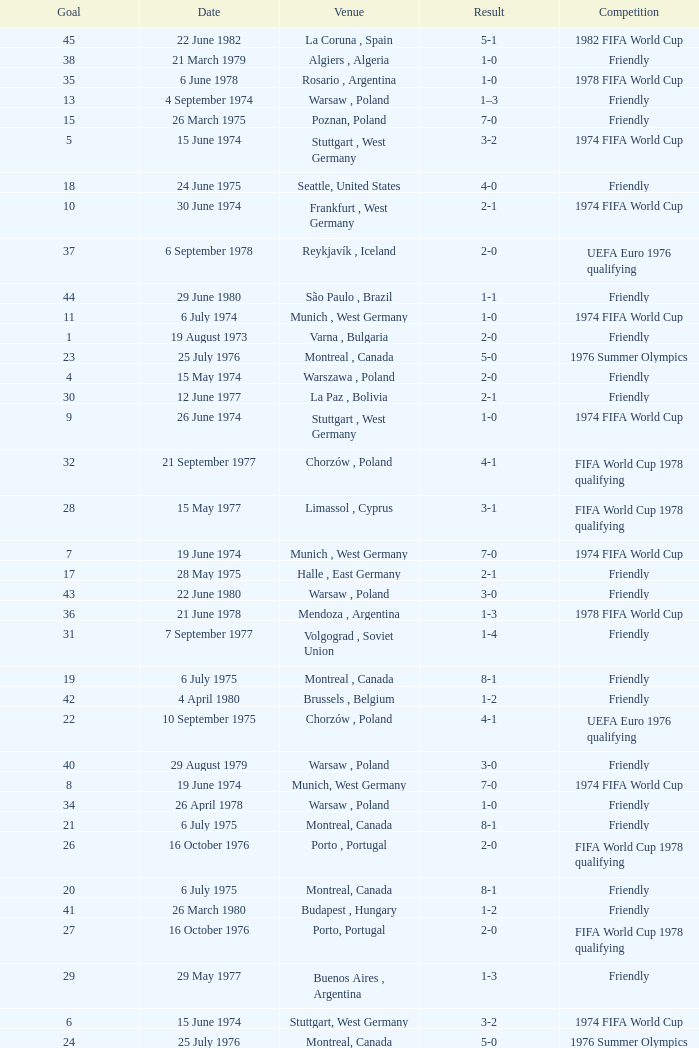Parse the table in full. {'header': ['Goal', 'Date', 'Venue', 'Result', 'Competition'], 'rows': [['45', '22 June 1982', 'La Coruna , Spain', '5-1', '1982 FIFA World Cup'], ['38', '21 March 1979', 'Algiers , Algeria', '1-0', 'Friendly'], ['35', '6 June 1978', 'Rosario , Argentina', '1-0', '1978 FIFA World Cup'], ['13', '4 September 1974', 'Warsaw , Poland', '1–3', 'Friendly'], ['15', '26 March 1975', 'Poznan, Poland', '7-0', 'Friendly'], ['5', '15 June 1974', 'Stuttgart , West Germany', '3-2', '1974 FIFA World Cup'], ['18', '24 June 1975', 'Seattle, United States', '4-0', 'Friendly'], ['10', '30 June 1974', 'Frankfurt , West Germany', '2-1', '1974 FIFA World Cup'], ['37', '6 September 1978', 'Reykjavík , Iceland', '2-0', 'UEFA Euro 1976 qualifying'], ['44', '29 June 1980', 'São Paulo , Brazil', '1-1', 'Friendly'], ['11', '6 July 1974', 'Munich , West Germany', '1-0', '1974 FIFA World Cup'], ['1', '19 August 1973', 'Varna , Bulgaria', '2-0', 'Friendly'], ['23', '25 July 1976', 'Montreal , Canada', '5-0', '1976 Summer Olympics'], ['4', '15 May 1974', 'Warszawa , Poland', '2-0', 'Friendly'], ['30', '12 June 1977', 'La Paz , Bolivia', '2-1', 'Friendly'], ['9', '26 June 1974', 'Stuttgart , West Germany', '1-0', '1974 FIFA World Cup'], ['32', '21 September 1977', 'Chorzów , Poland', '4-1', 'FIFA World Cup 1978 qualifying'], ['28', '15 May 1977', 'Limassol , Cyprus', '3-1', 'FIFA World Cup 1978 qualifying'], ['7', '19 June 1974', 'Munich , West Germany', '7-0', '1974 FIFA World Cup'], ['17', '28 May 1975', 'Halle , East Germany', '2-1', 'Friendly'], ['43', '22 June 1980', 'Warsaw , Poland', '3-0', 'Friendly'], ['36', '21 June 1978', 'Mendoza , Argentina', '1-3', '1978 FIFA World Cup'], ['31', '7 September 1977', 'Volgograd , Soviet Union', '1-4', 'Friendly'], ['19', '6 July 1975', 'Montreal , Canada', '8-1', 'Friendly'], ['42', '4 April 1980', 'Brussels , Belgium', '1-2', 'Friendly'], ['22', '10 September 1975', 'Chorzów , Poland', '4-1', 'UEFA Euro 1976 qualifying'], ['40', '29 August 1979', 'Warsaw , Poland', '3-0', 'Friendly'], ['8', '19 June 1974', 'Munich, West Germany', '7-0', '1974 FIFA World Cup'], ['34', '26 April 1978', 'Warsaw , Poland', '1-0', 'Friendly'], ['21', '6 July 1975', 'Montreal, Canada', '8-1', 'Friendly'], ['26', '16 October 1976', 'Porto , Portugal', '2-0', 'FIFA World Cup 1978 qualifying'], ['20', '6 July 1975', 'Montreal, Canada', '8-1', 'Friendly'], ['41', '26 March 1980', 'Budapest , Hungary', '1-2', 'Friendly'], ['27', '16 October 1976', 'Porto, Portugal', '2-0', 'FIFA World Cup 1978 qualifying'], ['29', '29 May 1977', 'Buenos Aires , Argentina', '1-3', 'Friendly'], ['6', '15 June 1974', 'Stuttgart, West Germany', '3-2', '1974 FIFA World Cup'], ['24', '25 July 1976', 'Montreal, Canada', '5-0', '1976 Summer Olympics'], ['33', '5 April 1978', 'Poznan , Poland', '5-2', 'Friendly'], ['2', '19 August 1973', 'Varna, Bulgaria', '2-0', 'Friendly'], ['39', '4 April 1979', 'Chorzów , Poland', '1-1', 'Friendly'], ['14', '9 October 1974', 'Poznan , Poland', '3-0', 'UEFA Euro 1976 qualifying'], ['3', '26 September 1973', 'Chorzów , Poland', '3-0', 'FIFA World Cup 1974 qualifying'], ['25', '31 July 1976', 'Montreal, Canada', '1-3', '1976 Summer Olympics'], ['16', '26 March 1975', 'Poznan, Poland', '7-0', 'Friendly'], ['12', '1 September 1974', 'Helsinki , Finland', '2-1', 'UEFA Euro 1976 qualifying']]} What was the result of the game in Stuttgart, West Germany and a goal number of less than 9? 3-2, 3-2. 